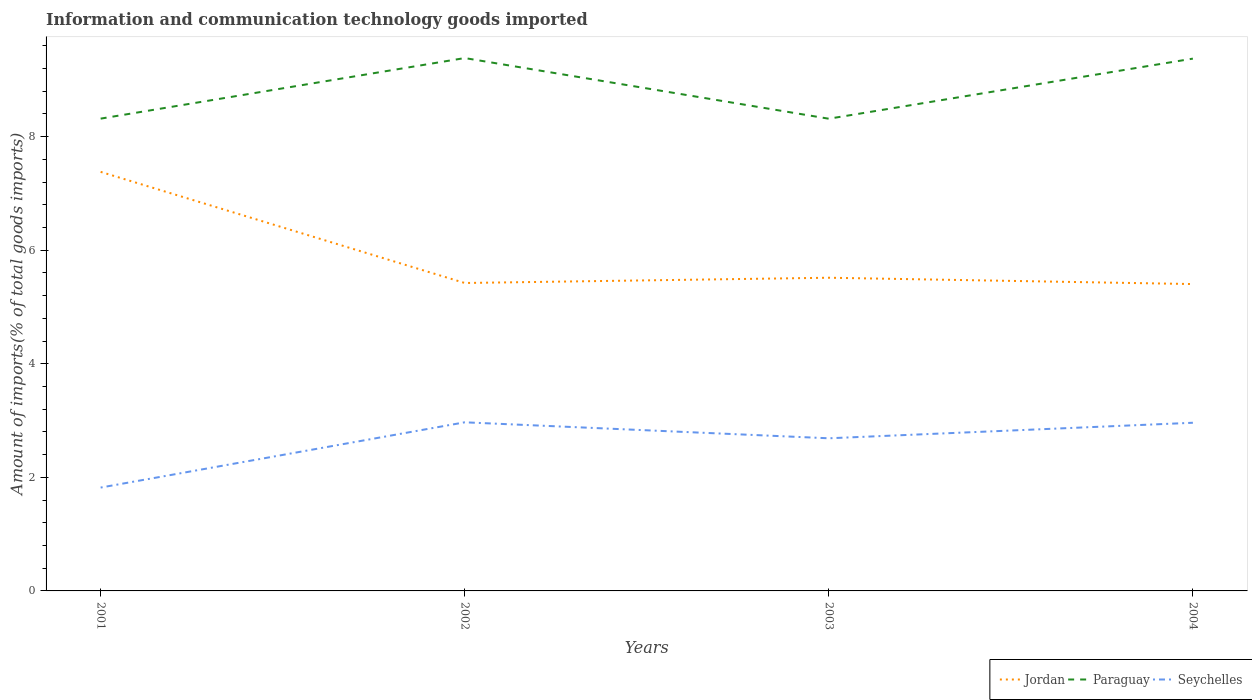How many different coloured lines are there?
Offer a very short reply. 3. Does the line corresponding to Jordan intersect with the line corresponding to Paraguay?
Keep it short and to the point. No. Is the number of lines equal to the number of legend labels?
Give a very brief answer. Yes. Across all years, what is the maximum amount of goods imported in Jordan?
Your answer should be very brief. 5.4. What is the total amount of goods imported in Jordan in the graph?
Give a very brief answer. 0.02. What is the difference between the highest and the second highest amount of goods imported in Seychelles?
Ensure brevity in your answer.  1.15. How many lines are there?
Give a very brief answer. 3. Are the values on the major ticks of Y-axis written in scientific E-notation?
Keep it short and to the point. No. Does the graph contain any zero values?
Offer a very short reply. No. Does the graph contain grids?
Provide a short and direct response. No. How many legend labels are there?
Offer a very short reply. 3. How are the legend labels stacked?
Ensure brevity in your answer.  Horizontal. What is the title of the graph?
Your answer should be very brief. Information and communication technology goods imported. Does "Thailand" appear as one of the legend labels in the graph?
Provide a short and direct response. No. What is the label or title of the X-axis?
Your answer should be compact. Years. What is the label or title of the Y-axis?
Make the answer very short. Amount of imports(% of total goods imports). What is the Amount of imports(% of total goods imports) of Jordan in 2001?
Offer a terse response. 7.38. What is the Amount of imports(% of total goods imports) in Paraguay in 2001?
Make the answer very short. 8.32. What is the Amount of imports(% of total goods imports) in Seychelles in 2001?
Keep it short and to the point. 1.82. What is the Amount of imports(% of total goods imports) of Jordan in 2002?
Make the answer very short. 5.42. What is the Amount of imports(% of total goods imports) in Paraguay in 2002?
Ensure brevity in your answer.  9.38. What is the Amount of imports(% of total goods imports) in Seychelles in 2002?
Your answer should be very brief. 2.97. What is the Amount of imports(% of total goods imports) of Jordan in 2003?
Provide a succinct answer. 5.51. What is the Amount of imports(% of total goods imports) of Paraguay in 2003?
Provide a succinct answer. 8.32. What is the Amount of imports(% of total goods imports) of Seychelles in 2003?
Offer a very short reply. 2.69. What is the Amount of imports(% of total goods imports) of Jordan in 2004?
Keep it short and to the point. 5.4. What is the Amount of imports(% of total goods imports) in Paraguay in 2004?
Offer a terse response. 9.37. What is the Amount of imports(% of total goods imports) of Seychelles in 2004?
Your answer should be compact. 2.96. Across all years, what is the maximum Amount of imports(% of total goods imports) in Jordan?
Offer a very short reply. 7.38. Across all years, what is the maximum Amount of imports(% of total goods imports) in Paraguay?
Make the answer very short. 9.38. Across all years, what is the maximum Amount of imports(% of total goods imports) of Seychelles?
Offer a terse response. 2.97. Across all years, what is the minimum Amount of imports(% of total goods imports) of Jordan?
Offer a very short reply. 5.4. Across all years, what is the minimum Amount of imports(% of total goods imports) in Paraguay?
Provide a short and direct response. 8.32. Across all years, what is the minimum Amount of imports(% of total goods imports) of Seychelles?
Provide a succinct answer. 1.82. What is the total Amount of imports(% of total goods imports) in Jordan in the graph?
Your response must be concise. 23.72. What is the total Amount of imports(% of total goods imports) in Paraguay in the graph?
Your answer should be very brief. 35.39. What is the total Amount of imports(% of total goods imports) in Seychelles in the graph?
Make the answer very short. 10.44. What is the difference between the Amount of imports(% of total goods imports) in Jordan in 2001 and that in 2002?
Make the answer very short. 1.96. What is the difference between the Amount of imports(% of total goods imports) of Paraguay in 2001 and that in 2002?
Make the answer very short. -1.07. What is the difference between the Amount of imports(% of total goods imports) of Seychelles in 2001 and that in 2002?
Your answer should be compact. -1.15. What is the difference between the Amount of imports(% of total goods imports) in Jordan in 2001 and that in 2003?
Offer a very short reply. 1.86. What is the difference between the Amount of imports(% of total goods imports) of Paraguay in 2001 and that in 2003?
Your answer should be very brief. 0. What is the difference between the Amount of imports(% of total goods imports) of Seychelles in 2001 and that in 2003?
Offer a very short reply. -0.87. What is the difference between the Amount of imports(% of total goods imports) in Jordan in 2001 and that in 2004?
Provide a short and direct response. 1.98. What is the difference between the Amount of imports(% of total goods imports) in Paraguay in 2001 and that in 2004?
Your answer should be very brief. -1.06. What is the difference between the Amount of imports(% of total goods imports) in Seychelles in 2001 and that in 2004?
Your response must be concise. -1.14. What is the difference between the Amount of imports(% of total goods imports) in Jordan in 2002 and that in 2003?
Ensure brevity in your answer.  -0.09. What is the difference between the Amount of imports(% of total goods imports) in Paraguay in 2002 and that in 2003?
Your answer should be very brief. 1.07. What is the difference between the Amount of imports(% of total goods imports) of Seychelles in 2002 and that in 2003?
Keep it short and to the point. 0.28. What is the difference between the Amount of imports(% of total goods imports) in Jordan in 2002 and that in 2004?
Your answer should be very brief. 0.02. What is the difference between the Amount of imports(% of total goods imports) in Paraguay in 2002 and that in 2004?
Ensure brevity in your answer.  0.01. What is the difference between the Amount of imports(% of total goods imports) in Seychelles in 2002 and that in 2004?
Offer a terse response. 0.01. What is the difference between the Amount of imports(% of total goods imports) in Jordan in 2003 and that in 2004?
Keep it short and to the point. 0.11. What is the difference between the Amount of imports(% of total goods imports) of Paraguay in 2003 and that in 2004?
Your response must be concise. -1.06. What is the difference between the Amount of imports(% of total goods imports) of Seychelles in 2003 and that in 2004?
Offer a very short reply. -0.27. What is the difference between the Amount of imports(% of total goods imports) in Jordan in 2001 and the Amount of imports(% of total goods imports) in Paraguay in 2002?
Offer a terse response. -2. What is the difference between the Amount of imports(% of total goods imports) of Jordan in 2001 and the Amount of imports(% of total goods imports) of Seychelles in 2002?
Offer a terse response. 4.41. What is the difference between the Amount of imports(% of total goods imports) of Paraguay in 2001 and the Amount of imports(% of total goods imports) of Seychelles in 2002?
Ensure brevity in your answer.  5.35. What is the difference between the Amount of imports(% of total goods imports) of Jordan in 2001 and the Amount of imports(% of total goods imports) of Paraguay in 2003?
Make the answer very short. -0.94. What is the difference between the Amount of imports(% of total goods imports) of Jordan in 2001 and the Amount of imports(% of total goods imports) of Seychelles in 2003?
Give a very brief answer. 4.69. What is the difference between the Amount of imports(% of total goods imports) of Paraguay in 2001 and the Amount of imports(% of total goods imports) of Seychelles in 2003?
Ensure brevity in your answer.  5.63. What is the difference between the Amount of imports(% of total goods imports) in Jordan in 2001 and the Amount of imports(% of total goods imports) in Paraguay in 2004?
Your answer should be very brief. -1.99. What is the difference between the Amount of imports(% of total goods imports) in Jordan in 2001 and the Amount of imports(% of total goods imports) in Seychelles in 2004?
Provide a short and direct response. 4.42. What is the difference between the Amount of imports(% of total goods imports) of Paraguay in 2001 and the Amount of imports(% of total goods imports) of Seychelles in 2004?
Offer a very short reply. 5.36. What is the difference between the Amount of imports(% of total goods imports) of Jordan in 2002 and the Amount of imports(% of total goods imports) of Paraguay in 2003?
Make the answer very short. -2.89. What is the difference between the Amount of imports(% of total goods imports) of Jordan in 2002 and the Amount of imports(% of total goods imports) of Seychelles in 2003?
Ensure brevity in your answer.  2.73. What is the difference between the Amount of imports(% of total goods imports) of Paraguay in 2002 and the Amount of imports(% of total goods imports) of Seychelles in 2003?
Ensure brevity in your answer.  6.7. What is the difference between the Amount of imports(% of total goods imports) in Jordan in 2002 and the Amount of imports(% of total goods imports) in Paraguay in 2004?
Provide a short and direct response. -3.95. What is the difference between the Amount of imports(% of total goods imports) in Jordan in 2002 and the Amount of imports(% of total goods imports) in Seychelles in 2004?
Ensure brevity in your answer.  2.46. What is the difference between the Amount of imports(% of total goods imports) of Paraguay in 2002 and the Amount of imports(% of total goods imports) of Seychelles in 2004?
Offer a very short reply. 6.42. What is the difference between the Amount of imports(% of total goods imports) in Jordan in 2003 and the Amount of imports(% of total goods imports) in Paraguay in 2004?
Your answer should be compact. -3.86. What is the difference between the Amount of imports(% of total goods imports) of Jordan in 2003 and the Amount of imports(% of total goods imports) of Seychelles in 2004?
Keep it short and to the point. 2.55. What is the difference between the Amount of imports(% of total goods imports) in Paraguay in 2003 and the Amount of imports(% of total goods imports) in Seychelles in 2004?
Provide a short and direct response. 5.35. What is the average Amount of imports(% of total goods imports) of Jordan per year?
Your answer should be compact. 5.93. What is the average Amount of imports(% of total goods imports) of Paraguay per year?
Ensure brevity in your answer.  8.85. What is the average Amount of imports(% of total goods imports) of Seychelles per year?
Ensure brevity in your answer.  2.61. In the year 2001, what is the difference between the Amount of imports(% of total goods imports) in Jordan and Amount of imports(% of total goods imports) in Paraguay?
Provide a succinct answer. -0.94. In the year 2001, what is the difference between the Amount of imports(% of total goods imports) in Jordan and Amount of imports(% of total goods imports) in Seychelles?
Your answer should be compact. 5.56. In the year 2001, what is the difference between the Amount of imports(% of total goods imports) in Paraguay and Amount of imports(% of total goods imports) in Seychelles?
Provide a succinct answer. 6.5. In the year 2002, what is the difference between the Amount of imports(% of total goods imports) in Jordan and Amount of imports(% of total goods imports) in Paraguay?
Provide a short and direct response. -3.96. In the year 2002, what is the difference between the Amount of imports(% of total goods imports) of Jordan and Amount of imports(% of total goods imports) of Seychelles?
Offer a very short reply. 2.45. In the year 2002, what is the difference between the Amount of imports(% of total goods imports) of Paraguay and Amount of imports(% of total goods imports) of Seychelles?
Offer a terse response. 6.41. In the year 2003, what is the difference between the Amount of imports(% of total goods imports) of Jordan and Amount of imports(% of total goods imports) of Seychelles?
Provide a succinct answer. 2.83. In the year 2003, what is the difference between the Amount of imports(% of total goods imports) of Paraguay and Amount of imports(% of total goods imports) of Seychelles?
Provide a short and direct response. 5.63. In the year 2004, what is the difference between the Amount of imports(% of total goods imports) in Jordan and Amount of imports(% of total goods imports) in Paraguay?
Offer a very short reply. -3.97. In the year 2004, what is the difference between the Amount of imports(% of total goods imports) in Jordan and Amount of imports(% of total goods imports) in Seychelles?
Provide a short and direct response. 2.44. In the year 2004, what is the difference between the Amount of imports(% of total goods imports) in Paraguay and Amount of imports(% of total goods imports) in Seychelles?
Provide a succinct answer. 6.41. What is the ratio of the Amount of imports(% of total goods imports) in Jordan in 2001 to that in 2002?
Provide a short and direct response. 1.36. What is the ratio of the Amount of imports(% of total goods imports) of Paraguay in 2001 to that in 2002?
Provide a succinct answer. 0.89. What is the ratio of the Amount of imports(% of total goods imports) in Seychelles in 2001 to that in 2002?
Ensure brevity in your answer.  0.61. What is the ratio of the Amount of imports(% of total goods imports) in Jordan in 2001 to that in 2003?
Provide a short and direct response. 1.34. What is the ratio of the Amount of imports(% of total goods imports) of Paraguay in 2001 to that in 2003?
Your response must be concise. 1. What is the ratio of the Amount of imports(% of total goods imports) of Seychelles in 2001 to that in 2003?
Provide a short and direct response. 0.68. What is the ratio of the Amount of imports(% of total goods imports) in Jordan in 2001 to that in 2004?
Ensure brevity in your answer.  1.37. What is the ratio of the Amount of imports(% of total goods imports) of Paraguay in 2001 to that in 2004?
Make the answer very short. 0.89. What is the ratio of the Amount of imports(% of total goods imports) in Seychelles in 2001 to that in 2004?
Ensure brevity in your answer.  0.61. What is the ratio of the Amount of imports(% of total goods imports) in Jordan in 2002 to that in 2003?
Give a very brief answer. 0.98. What is the ratio of the Amount of imports(% of total goods imports) in Paraguay in 2002 to that in 2003?
Your answer should be very brief. 1.13. What is the ratio of the Amount of imports(% of total goods imports) of Seychelles in 2002 to that in 2003?
Make the answer very short. 1.1. What is the ratio of the Amount of imports(% of total goods imports) of Jordan in 2002 to that in 2004?
Make the answer very short. 1. What is the ratio of the Amount of imports(% of total goods imports) of Paraguay in 2002 to that in 2004?
Keep it short and to the point. 1. What is the ratio of the Amount of imports(% of total goods imports) in Jordan in 2003 to that in 2004?
Provide a succinct answer. 1.02. What is the ratio of the Amount of imports(% of total goods imports) in Paraguay in 2003 to that in 2004?
Your answer should be compact. 0.89. What is the ratio of the Amount of imports(% of total goods imports) of Seychelles in 2003 to that in 2004?
Provide a short and direct response. 0.91. What is the difference between the highest and the second highest Amount of imports(% of total goods imports) in Jordan?
Offer a terse response. 1.86. What is the difference between the highest and the second highest Amount of imports(% of total goods imports) in Paraguay?
Offer a terse response. 0.01. What is the difference between the highest and the second highest Amount of imports(% of total goods imports) in Seychelles?
Offer a very short reply. 0.01. What is the difference between the highest and the lowest Amount of imports(% of total goods imports) in Jordan?
Provide a succinct answer. 1.98. What is the difference between the highest and the lowest Amount of imports(% of total goods imports) in Paraguay?
Make the answer very short. 1.07. What is the difference between the highest and the lowest Amount of imports(% of total goods imports) in Seychelles?
Keep it short and to the point. 1.15. 